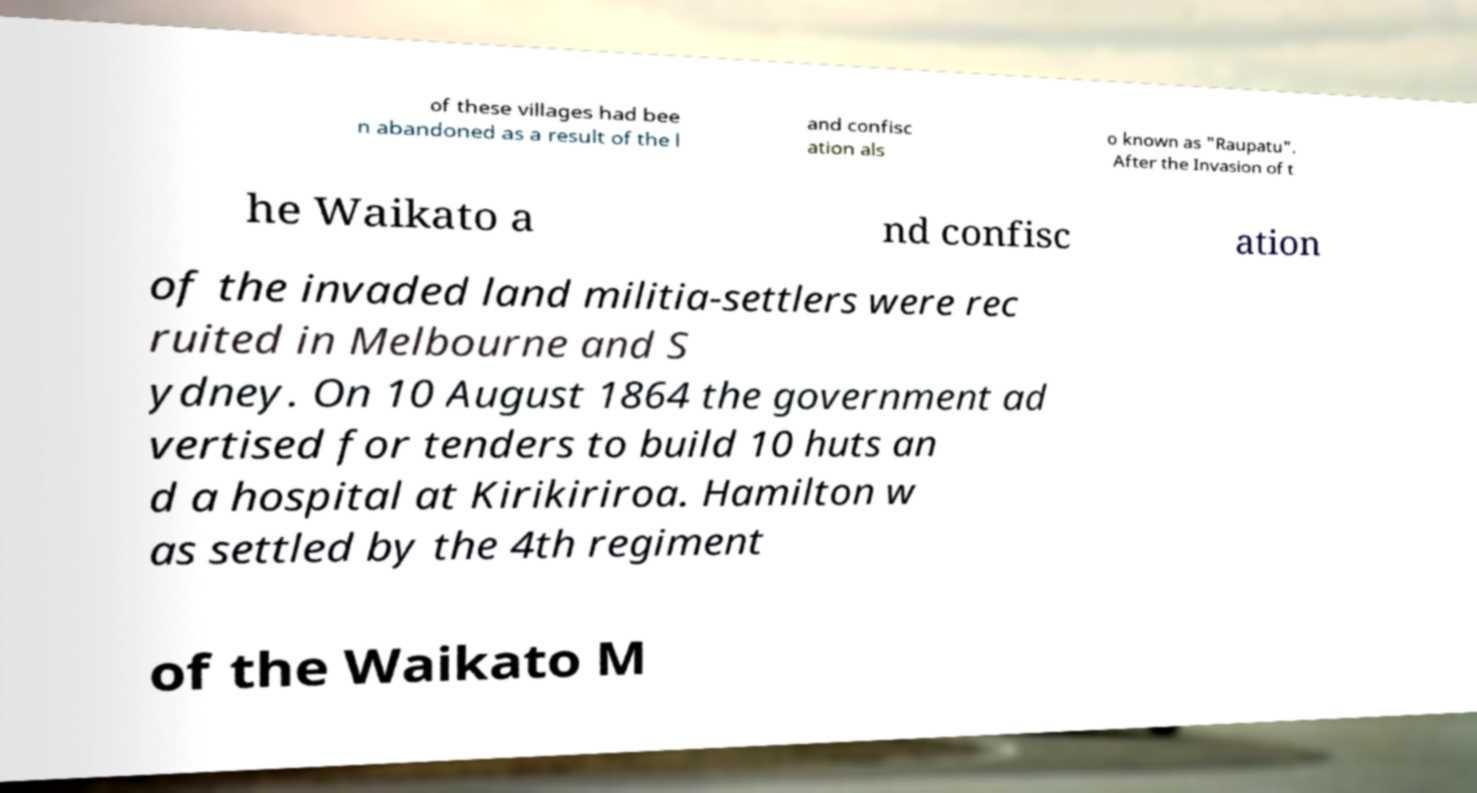Can you read and provide the text displayed in the image?This photo seems to have some interesting text. Can you extract and type it out for me? of these villages had bee n abandoned as a result of the l and confisc ation als o known as "Raupatu". After the Invasion of t he Waikato a nd confisc ation of the invaded land militia-settlers were rec ruited in Melbourne and S ydney. On 10 August 1864 the government ad vertised for tenders to build 10 huts an d a hospital at Kirikiriroa. Hamilton w as settled by the 4th regiment of the Waikato M 